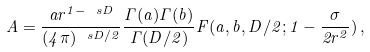Convert formula to latex. <formula><loc_0><loc_0><loc_500><loc_500>A = \frac { a r ^ { 1 - \ s D } } { ( 4 \pi ) ^ { \ s D / 2 } } \frac { \Gamma ( a ) \Gamma ( b ) } { \Gamma ( D / 2 ) } F ( a , b , D / 2 ; 1 - \frac { \sigma } { 2 r ^ { 2 } } ) \, ,</formula> 